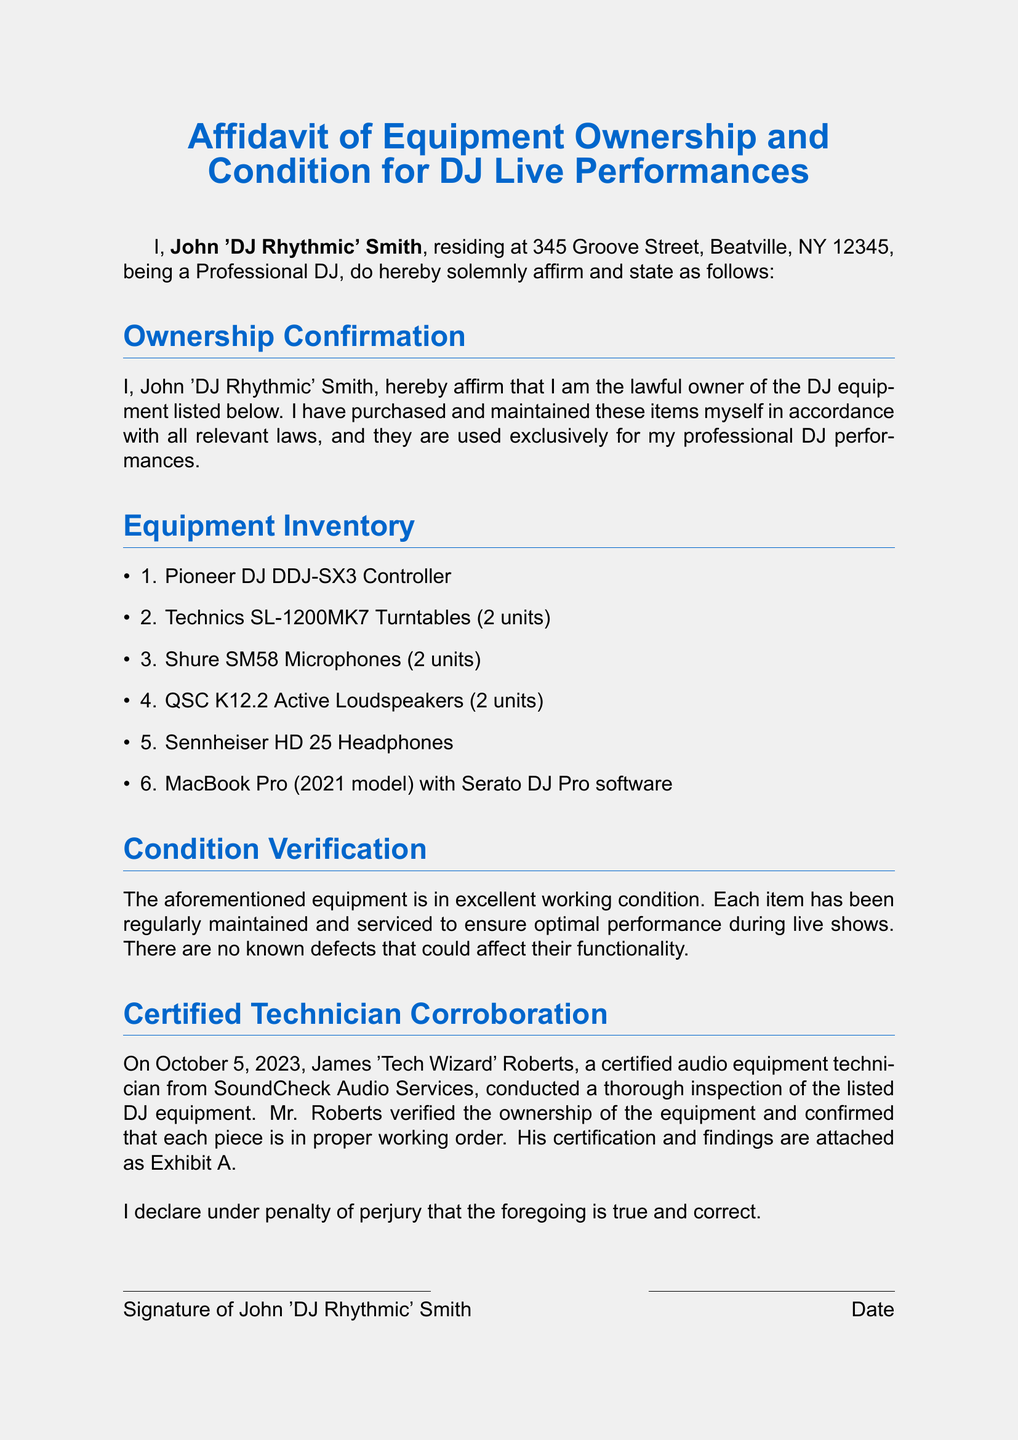What is the name of the DJ? The document states the name of the DJ as John 'DJ Rhythmic' Smith.
Answer: John 'DJ Rhythmic' Smith What is the address of the DJ? The DJ's residence is listed as 345 Groove Street, Beatville, NY 12345.
Answer: 345 Groove Street, Beatville, NY 12345 How many turntables are listed? The document specifies that there are two Technics SL-1200MK7 Turntables.
Answer: 2 units Who conducted the equipment inspection? The certified technician who inspected the equipment is named James 'Tech Wizard' Roberts.
Answer: James 'Tech Wizard' Roberts When was the equipment inspected? The inspection date is mentioned as October 5, 2023.
Answer: October 5, 2023 What software is used on the MacBook Pro? The document lists Serato DJ Pro as the software installed on the MacBook Pro.
Answer: Serato DJ Pro Which company conducted the equipment inspection? The equipment inspection was conducted by SoundCheck Audio Services.
Answer: SoundCheck Audio Services What is the condition of the equipment? The affidavit states that the equipment is in excellent working condition.
Answer: Excellent working condition What does the DJ declare under penalty of? The DJ declares under penalty of perjury that the information is true and correct.
Answer: Perjury 